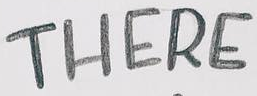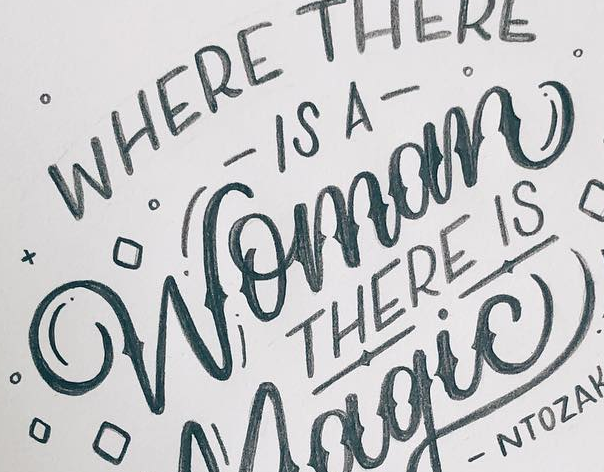Read the text from these images in sequence, separated by a semicolon. THERE; Womom 